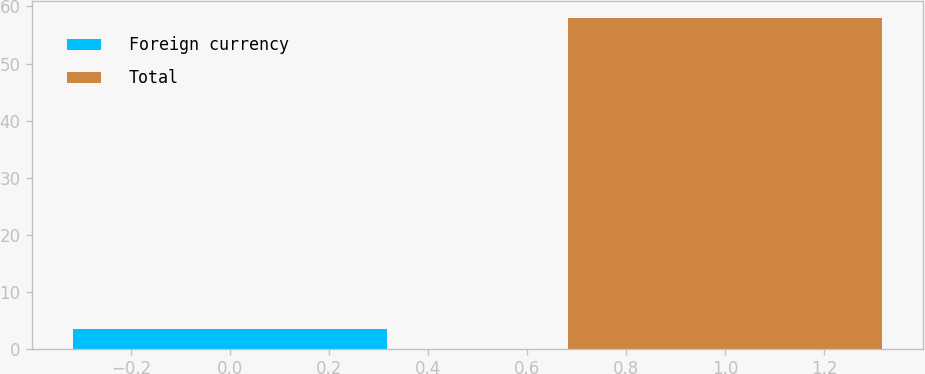Convert chart. <chart><loc_0><loc_0><loc_500><loc_500><bar_chart><fcel>Foreign currency<fcel>Total<nl><fcel>3.5<fcel>58<nl></chart> 